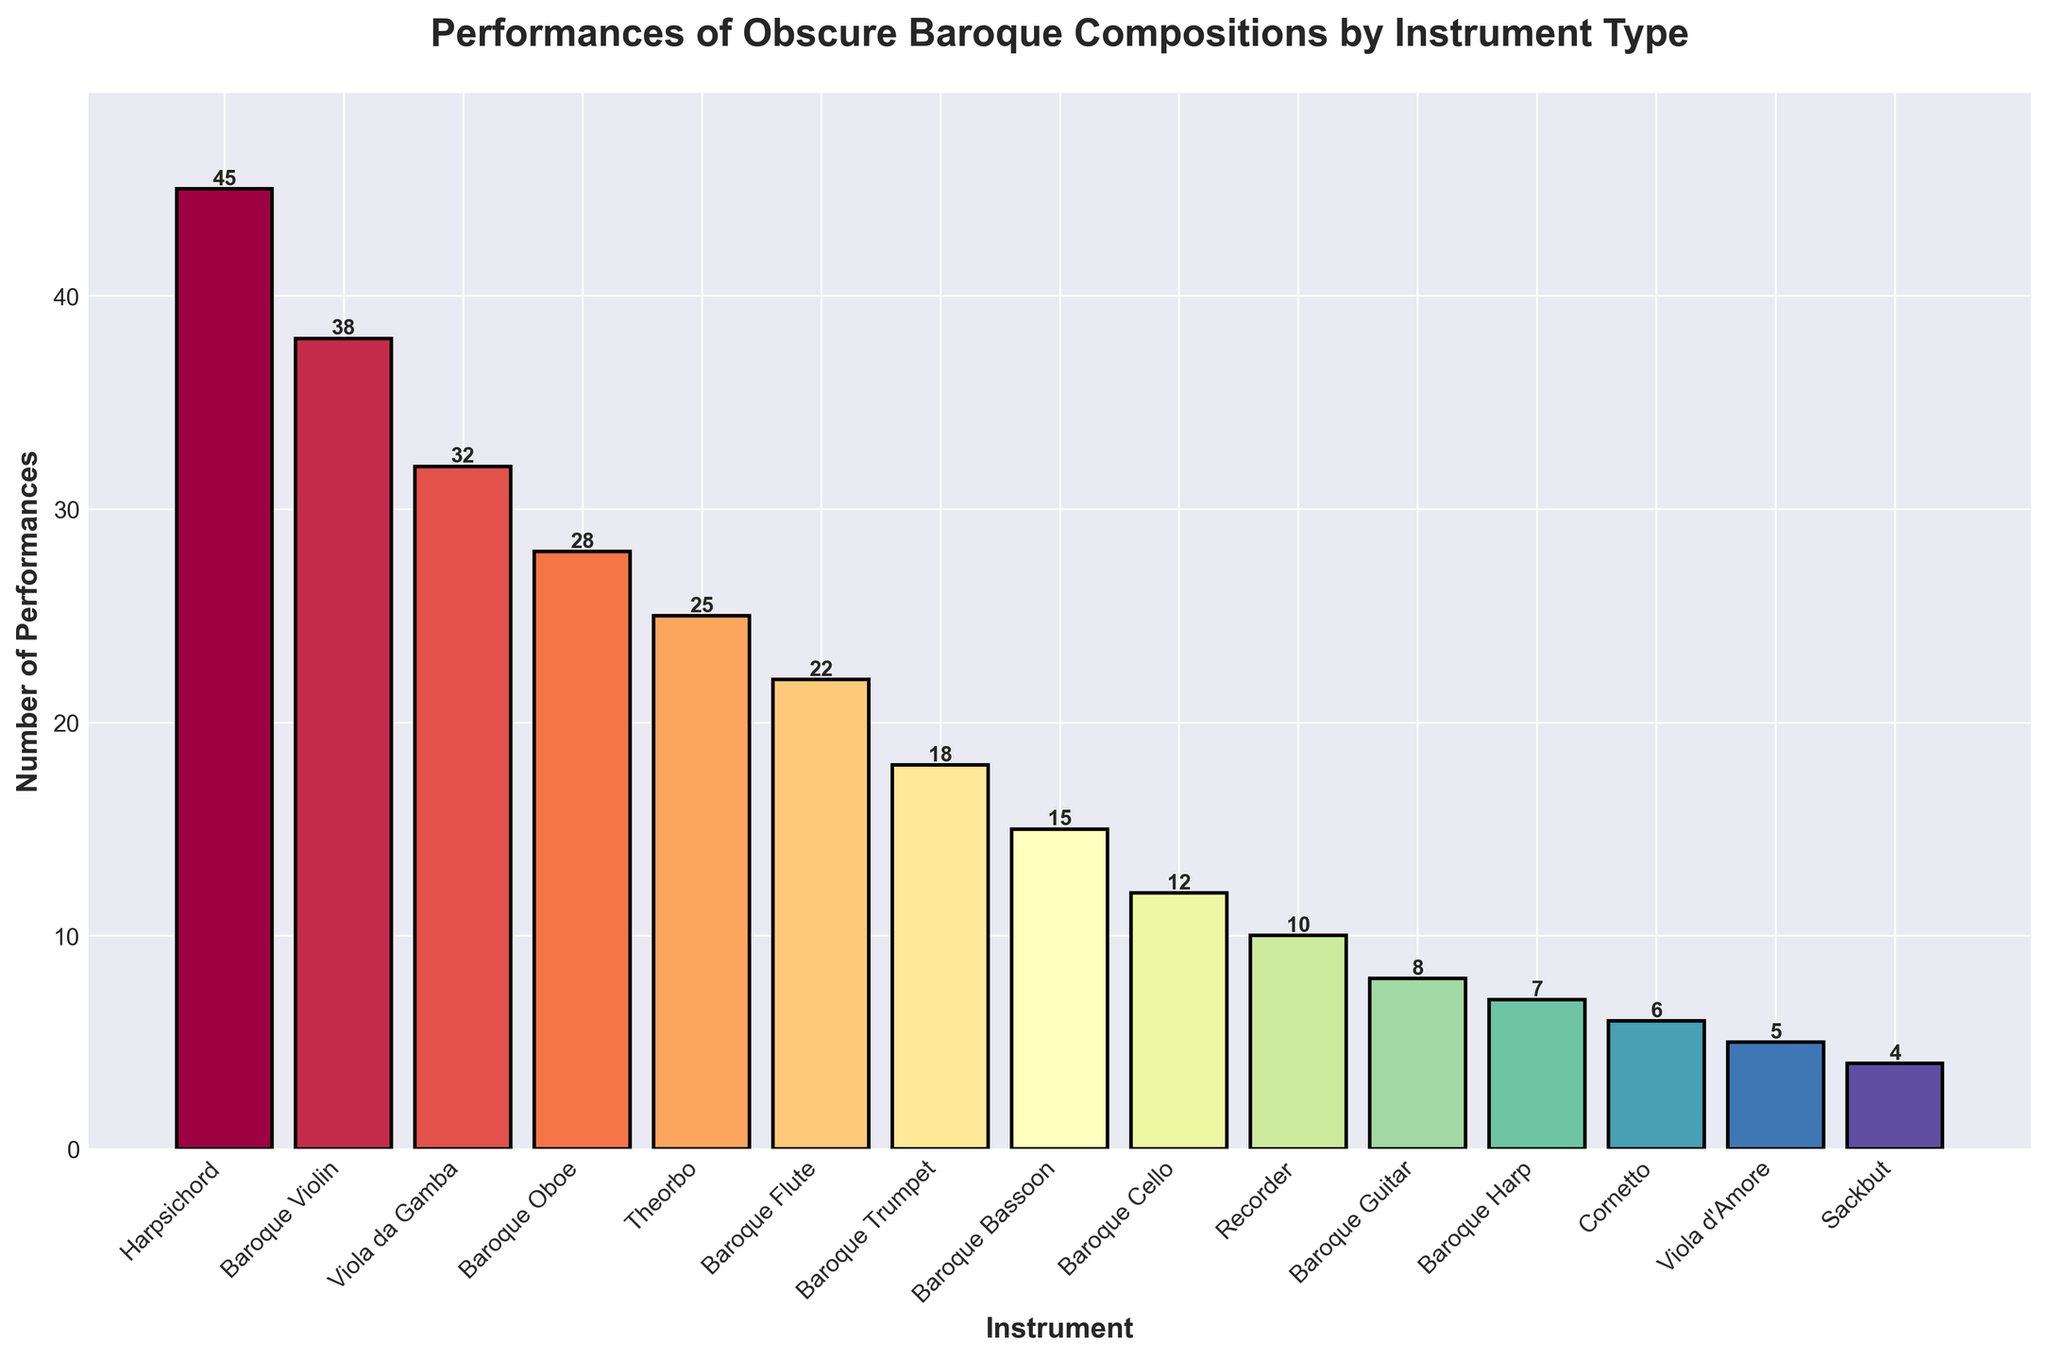Which instrument has the highest number of performances? The harpsichord has the highest bar in the chart. By examining the height of the bars, it is clear that the harpsichord has the most performances.
Answer: Harpsichord How many more performances does the Baroque Violin have compared to the Baroque Guitar? The Baroque Violin has 38 performances, and the Baroque Guitar has 8 performances. Subtracting 8 from 38 gives 30 more performances.
Answer: 30 Which instruments have fewer than 10 performances? The instruments with bars lower than the 10 mark are Cornetto, Viola d'Amore, and Sackbut.
Answer: Cornetto, Viola d'Amore, Sackbut What is the total number of performances for wind instruments (Baroque Flute, Recorder, Baroque Oboe, Cornetto, Sackbut, Baroque Trumpet, and Baroque Bassoon)? Summing the performances of Baroque Flute (22), Recorder (10), Baroque Oboe (28), Cornetto (6), Sackbut (4), Baroque Trumpet (18), and Baroque Bassoon (15): 22 + 10 + 28 + 6 + 4 + 18 + 15 = 103.
Answer: 103 Which instrument has the lowest number of performances and how many does it have? The Sackbut has the shortest bar in the chart, indicating it has the lowest number of performances. By reading the height, it has 4 performances.
Answer: Sackbut, 4 How does the number of performances for the Viola da Gamba compare to that of the Baroque Cello? The Viola da Gamba has 32 performances, whereas the Baroque Cello has 12 performances. 32 is greater than 12.
Answer: Viola da Gamba has more performances For which instruments do the colors in the bar chart transition from warm to cool tones visually? The colors transition from warm tones in the Harpsichord, Baroque Violin, Viola da Gamba, and Baroque Oboe to cooler tones in instruments like Theorbo, Baroque Flute, and below.
Answer: After Baroque Oboe What's the average number of performances for the top 5 instruments? The top 5 instruments are Harpsichord (45), Baroque Violin (38), Viola da Gamba (32), Baroque Oboe (28), and Theorbo (25). The total is 45 + 38 + 32 + 28 + 25 = 168. Dividing by 5, the average is 168 / 5 = 33.6.
Answer: 33.6 How much higher is the bar for the Harpsichord compared to the Baroque Violin? The Harpsichord has 45 performances, while the Baroque Violin has 38. The difference is 45 - 38 = 7.
Answer: 7 Which two instruments have a combined total of exactly 40 performances? Checking pairs, Theorbo (25) and Baroque Guitar (8) don't add up to 40. Baroque Violin (38) and Viola d'Amore (5) add up to 43. Continuing this check, Baroque Flute (22) and Recorder (10) add up to 32, but Baroque Flute (22) and Cornetto (6) add up to 28. Finally, Baroque Trumpet (18) and Baroque Cello (12) add up to 30. After checking all pairs, no two instruments exactly add up to 40 performances in the given data.
Answer: None 